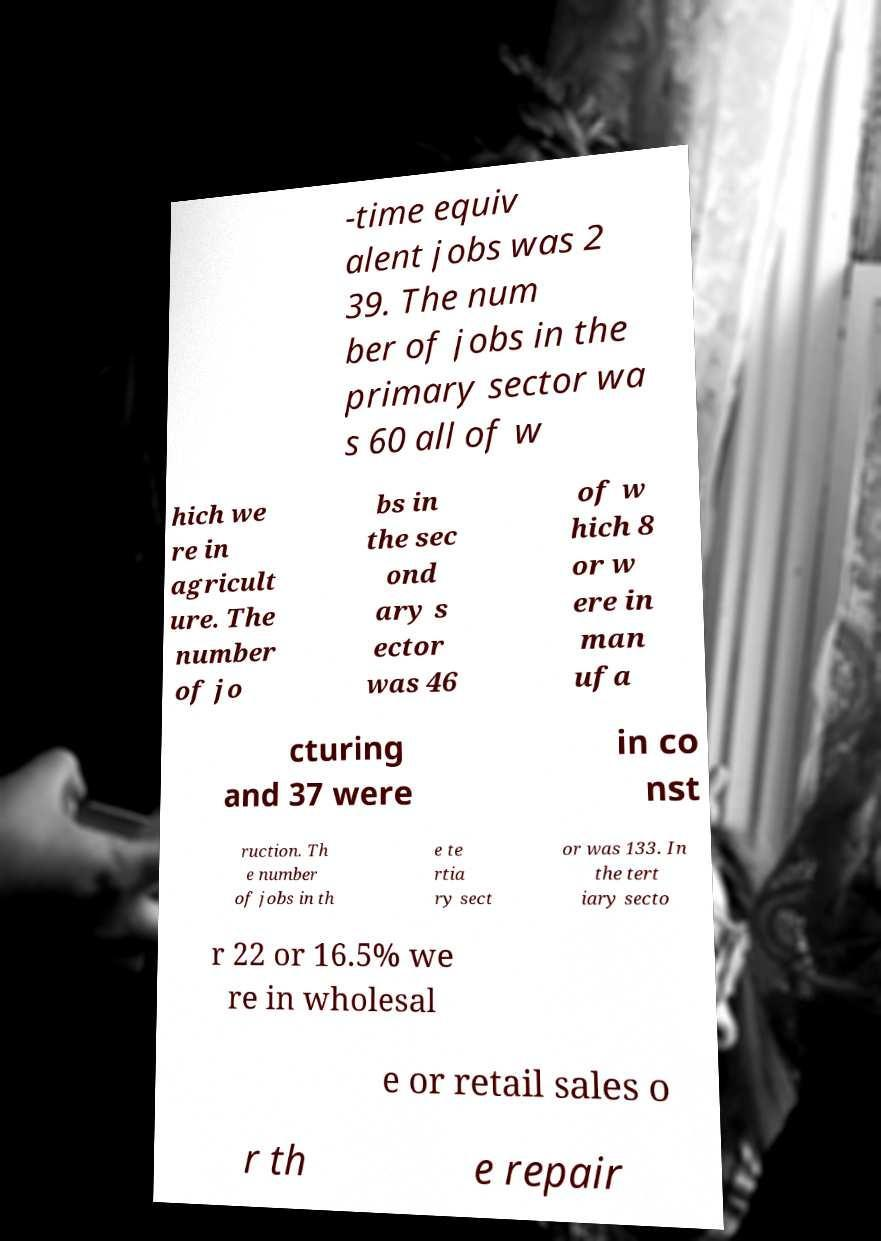Could you assist in decoding the text presented in this image and type it out clearly? -time equiv alent jobs was 2 39. The num ber of jobs in the primary sector wa s 60 all of w hich we re in agricult ure. The number of jo bs in the sec ond ary s ector was 46 of w hich 8 or w ere in man ufa cturing and 37 were in co nst ruction. Th e number of jobs in th e te rtia ry sect or was 133. In the tert iary secto r 22 or 16.5% we re in wholesal e or retail sales o r th e repair 